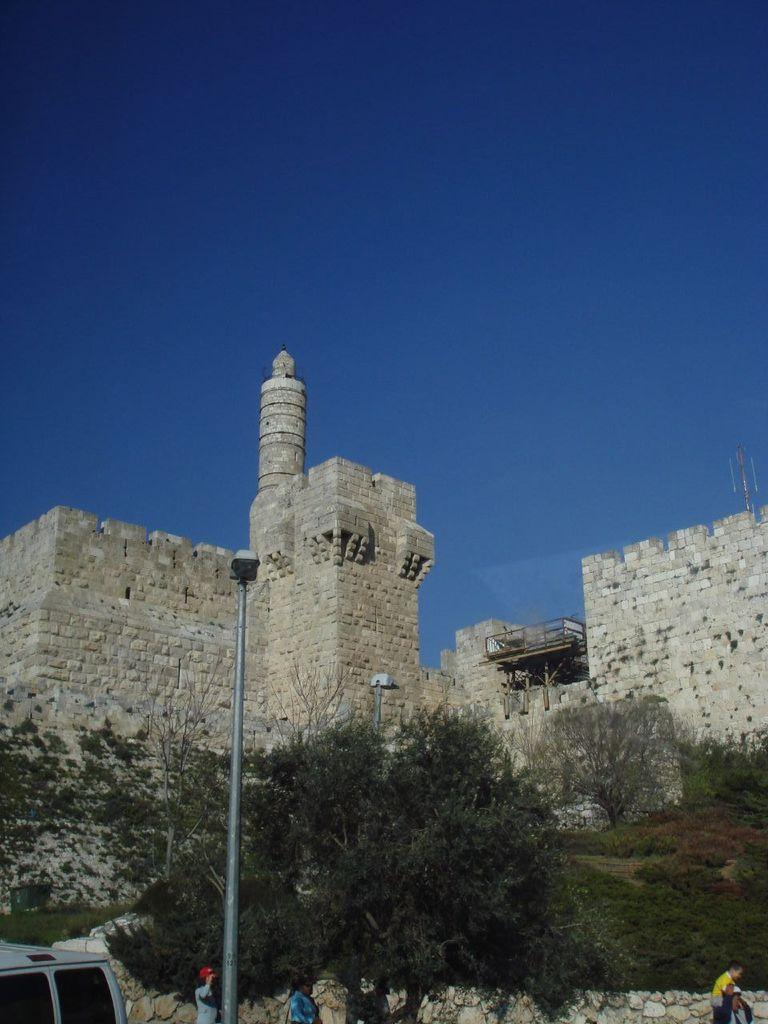What is the main object in the image? There is a pole in the image. What else can be seen in the image besides the pole? There are people standing in the image. What is visible in the background of the image? There are trees and a fort in the background of the image, as well as the sky. What type of fruit is hanging from the pole in the image? There is no fruit hanging from the pole in the image. How does the machine in the image help the people standing nearby? There is no machine present in the image. 